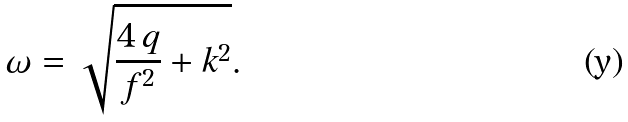Convert formula to latex. <formula><loc_0><loc_0><loc_500><loc_500>\omega = \sqrt { \frac { 4 \, q } { f ^ { 2 } } + k ^ { 2 } } .</formula> 